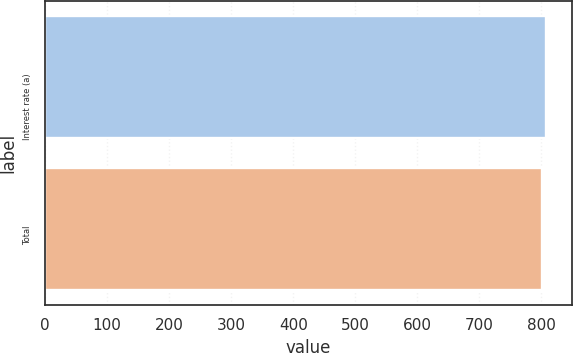<chart> <loc_0><loc_0><loc_500><loc_500><bar_chart><fcel>Interest rate (a)<fcel>Total<nl><fcel>808<fcel>801<nl></chart> 